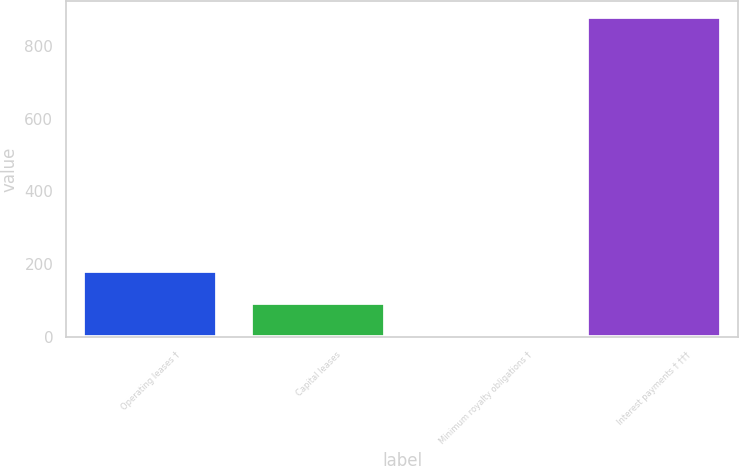Convert chart to OTSL. <chart><loc_0><loc_0><loc_500><loc_500><bar_chart><fcel>Operating leases †<fcel>Capital leases<fcel>Minimum royalty obligations †<fcel>Interest payments † †††<nl><fcel>180.8<fcel>93.4<fcel>6<fcel>880<nl></chart> 